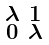Convert formula to latex. <formula><loc_0><loc_0><loc_500><loc_500>\begin{smallmatrix} \lambda & 1 \\ 0 & \lambda \end{smallmatrix}</formula> 